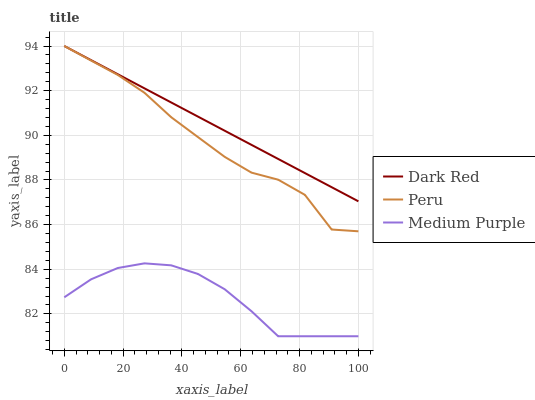Does Medium Purple have the minimum area under the curve?
Answer yes or no. Yes. Does Dark Red have the maximum area under the curve?
Answer yes or no. Yes. Does Peru have the minimum area under the curve?
Answer yes or no. No. Does Peru have the maximum area under the curve?
Answer yes or no. No. Is Dark Red the smoothest?
Answer yes or no. Yes. Is Peru the roughest?
Answer yes or no. Yes. Is Peru the smoothest?
Answer yes or no. No. Is Dark Red the roughest?
Answer yes or no. No. Does Medium Purple have the lowest value?
Answer yes or no. Yes. Does Peru have the lowest value?
Answer yes or no. No. Does Peru have the highest value?
Answer yes or no. Yes. Is Medium Purple less than Peru?
Answer yes or no. Yes. Is Peru greater than Medium Purple?
Answer yes or no. Yes. Does Dark Red intersect Peru?
Answer yes or no. Yes. Is Dark Red less than Peru?
Answer yes or no. No. Is Dark Red greater than Peru?
Answer yes or no. No. Does Medium Purple intersect Peru?
Answer yes or no. No. 